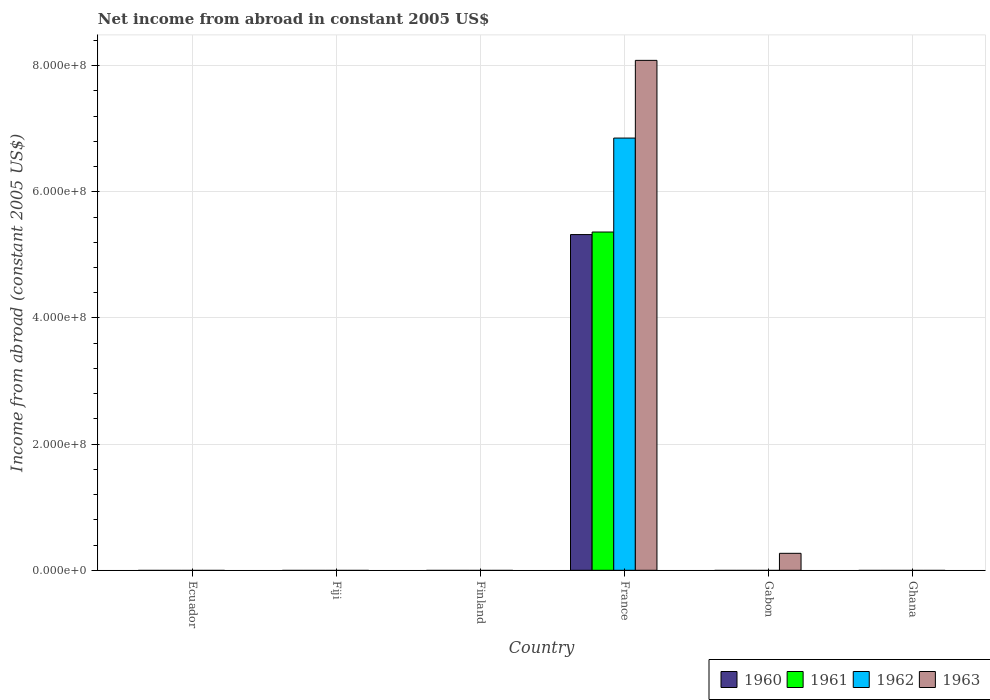Are the number of bars on each tick of the X-axis equal?
Your response must be concise. No. How many bars are there on the 3rd tick from the right?
Provide a succinct answer. 4. What is the label of the 6th group of bars from the left?
Provide a succinct answer. Ghana. In how many cases, is the number of bars for a given country not equal to the number of legend labels?
Provide a short and direct response. 5. What is the net income from abroad in 1961 in Gabon?
Provide a succinct answer. 0. Across all countries, what is the maximum net income from abroad in 1963?
Offer a terse response. 8.08e+08. In which country was the net income from abroad in 1960 maximum?
Offer a terse response. France. What is the total net income from abroad in 1960 in the graph?
Your response must be concise. 5.32e+08. What is the difference between the net income from abroad in 1963 in France and that in Gabon?
Your answer should be compact. 7.81e+08. What is the difference between the net income from abroad in 1960 in Fiji and the net income from abroad in 1962 in Gabon?
Offer a terse response. 0. What is the average net income from abroad in 1960 per country?
Ensure brevity in your answer.  8.87e+07. What is the difference between the net income from abroad of/in 1962 and net income from abroad of/in 1961 in France?
Make the answer very short. 1.49e+08. In how many countries, is the net income from abroad in 1960 greater than 200000000 US$?
Make the answer very short. 1. What is the difference between the highest and the lowest net income from abroad in 1962?
Offer a terse response. 6.85e+08. In how many countries, is the net income from abroad in 1963 greater than the average net income from abroad in 1963 taken over all countries?
Provide a succinct answer. 1. Is it the case that in every country, the sum of the net income from abroad in 1961 and net income from abroad in 1963 is greater than the sum of net income from abroad in 1962 and net income from abroad in 1960?
Provide a short and direct response. No. Is it the case that in every country, the sum of the net income from abroad in 1960 and net income from abroad in 1961 is greater than the net income from abroad in 1963?
Keep it short and to the point. No. Are all the bars in the graph horizontal?
Provide a short and direct response. No. Are the values on the major ticks of Y-axis written in scientific E-notation?
Ensure brevity in your answer.  Yes. Does the graph contain any zero values?
Your answer should be compact. Yes. Does the graph contain grids?
Offer a terse response. Yes. Where does the legend appear in the graph?
Your response must be concise. Bottom right. How many legend labels are there?
Provide a short and direct response. 4. How are the legend labels stacked?
Your response must be concise. Horizontal. What is the title of the graph?
Your answer should be compact. Net income from abroad in constant 2005 US$. Does "1980" appear as one of the legend labels in the graph?
Your answer should be compact. No. What is the label or title of the X-axis?
Offer a very short reply. Country. What is the label or title of the Y-axis?
Your answer should be very brief. Income from abroad (constant 2005 US$). What is the Income from abroad (constant 2005 US$) in 1960 in Ecuador?
Offer a terse response. 0. What is the Income from abroad (constant 2005 US$) in 1963 in Ecuador?
Offer a very short reply. 0. What is the Income from abroad (constant 2005 US$) in 1960 in Fiji?
Your response must be concise. 0. What is the Income from abroad (constant 2005 US$) of 1961 in Fiji?
Make the answer very short. 0. What is the Income from abroad (constant 2005 US$) of 1963 in Fiji?
Make the answer very short. 0. What is the Income from abroad (constant 2005 US$) in 1960 in Finland?
Your answer should be very brief. 0. What is the Income from abroad (constant 2005 US$) in 1963 in Finland?
Your answer should be very brief. 0. What is the Income from abroad (constant 2005 US$) of 1960 in France?
Offer a very short reply. 5.32e+08. What is the Income from abroad (constant 2005 US$) in 1961 in France?
Make the answer very short. 5.36e+08. What is the Income from abroad (constant 2005 US$) in 1962 in France?
Provide a short and direct response. 6.85e+08. What is the Income from abroad (constant 2005 US$) of 1963 in France?
Provide a succinct answer. 8.08e+08. What is the Income from abroad (constant 2005 US$) of 1960 in Gabon?
Your response must be concise. 0. What is the Income from abroad (constant 2005 US$) of 1961 in Gabon?
Your response must be concise. 0. What is the Income from abroad (constant 2005 US$) of 1963 in Gabon?
Provide a succinct answer. 2.69e+07. What is the Income from abroad (constant 2005 US$) in 1961 in Ghana?
Your response must be concise. 0. What is the Income from abroad (constant 2005 US$) in 1962 in Ghana?
Your answer should be compact. 0. Across all countries, what is the maximum Income from abroad (constant 2005 US$) in 1960?
Your response must be concise. 5.32e+08. Across all countries, what is the maximum Income from abroad (constant 2005 US$) of 1961?
Ensure brevity in your answer.  5.36e+08. Across all countries, what is the maximum Income from abroad (constant 2005 US$) of 1962?
Your answer should be compact. 6.85e+08. Across all countries, what is the maximum Income from abroad (constant 2005 US$) in 1963?
Your answer should be very brief. 8.08e+08. What is the total Income from abroad (constant 2005 US$) of 1960 in the graph?
Your answer should be compact. 5.32e+08. What is the total Income from abroad (constant 2005 US$) of 1961 in the graph?
Ensure brevity in your answer.  5.36e+08. What is the total Income from abroad (constant 2005 US$) of 1962 in the graph?
Your response must be concise. 6.85e+08. What is the total Income from abroad (constant 2005 US$) of 1963 in the graph?
Make the answer very short. 8.35e+08. What is the difference between the Income from abroad (constant 2005 US$) of 1963 in France and that in Gabon?
Keep it short and to the point. 7.81e+08. What is the difference between the Income from abroad (constant 2005 US$) of 1960 in France and the Income from abroad (constant 2005 US$) of 1963 in Gabon?
Provide a succinct answer. 5.05e+08. What is the difference between the Income from abroad (constant 2005 US$) of 1961 in France and the Income from abroad (constant 2005 US$) of 1963 in Gabon?
Your answer should be compact. 5.09e+08. What is the difference between the Income from abroad (constant 2005 US$) in 1962 in France and the Income from abroad (constant 2005 US$) in 1963 in Gabon?
Ensure brevity in your answer.  6.58e+08. What is the average Income from abroad (constant 2005 US$) of 1960 per country?
Keep it short and to the point. 8.87e+07. What is the average Income from abroad (constant 2005 US$) in 1961 per country?
Your answer should be very brief. 8.94e+07. What is the average Income from abroad (constant 2005 US$) in 1962 per country?
Give a very brief answer. 1.14e+08. What is the average Income from abroad (constant 2005 US$) in 1963 per country?
Your answer should be very brief. 1.39e+08. What is the difference between the Income from abroad (constant 2005 US$) of 1960 and Income from abroad (constant 2005 US$) of 1961 in France?
Offer a very short reply. -4.05e+06. What is the difference between the Income from abroad (constant 2005 US$) of 1960 and Income from abroad (constant 2005 US$) of 1962 in France?
Give a very brief answer. -1.53e+08. What is the difference between the Income from abroad (constant 2005 US$) of 1960 and Income from abroad (constant 2005 US$) of 1963 in France?
Provide a succinct answer. -2.76e+08. What is the difference between the Income from abroad (constant 2005 US$) of 1961 and Income from abroad (constant 2005 US$) of 1962 in France?
Make the answer very short. -1.49e+08. What is the difference between the Income from abroad (constant 2005 US$) in 1961 and Income from abroad (constant 2005 US$) in 1963 in France?
Provide a succinct answer. -2.72e+08. What is the difference between the Income from abroad (constant 2005 US$) of 1962 and Income from abroad (constant 2005 US$) of 1963 in France?
Provide a short and direct response. -1.23e+08. What is the ratio of the Income from abroad (constant 2005 US$) of 1963 in France to that in Gabon?
Your answer should be very brief. 30.04. What is the difference between the highest and the lowest Income from abroad (constant 2005 US$) of 1960?
Provide a short and direct response. 5.32e+08. What is the difference between the highest and the lowest Income from abroad (constant 2005 US$) of 1961?
Keep it short and to the point. 5.36e+08. What is the difference between the highest and the lowest Income from abroad (constant 2005 US$) of 1962?
Make the answer very short. 6.85e+08. What is the difference between the highest and the lowest Income from abroad (constant 2005 US$) in 1963?
Ensure brevity in your answer.  8.08e+08. 